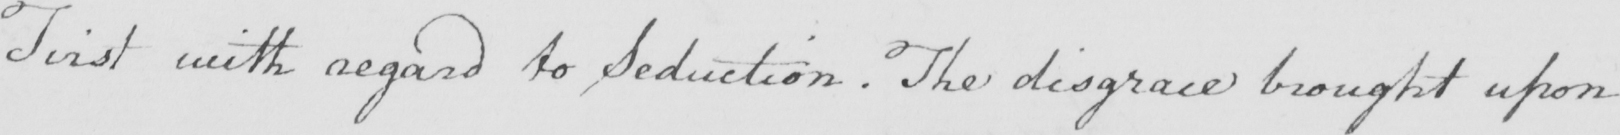Please provide the text content of this handwritten line. First with regard to Seduction . The disgrace brought upon 